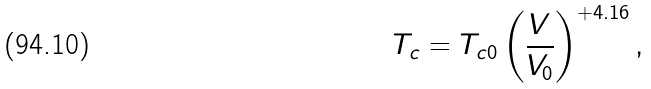Convert formula to latex. <formula><loc_0><loc_0><loc_500><loc_500>T _ { c } = T _ { c 0 } \left ( \frac { V } { V _ { 0 } } \right ) ^ { + 4 . 1 6 } ,</formula> 